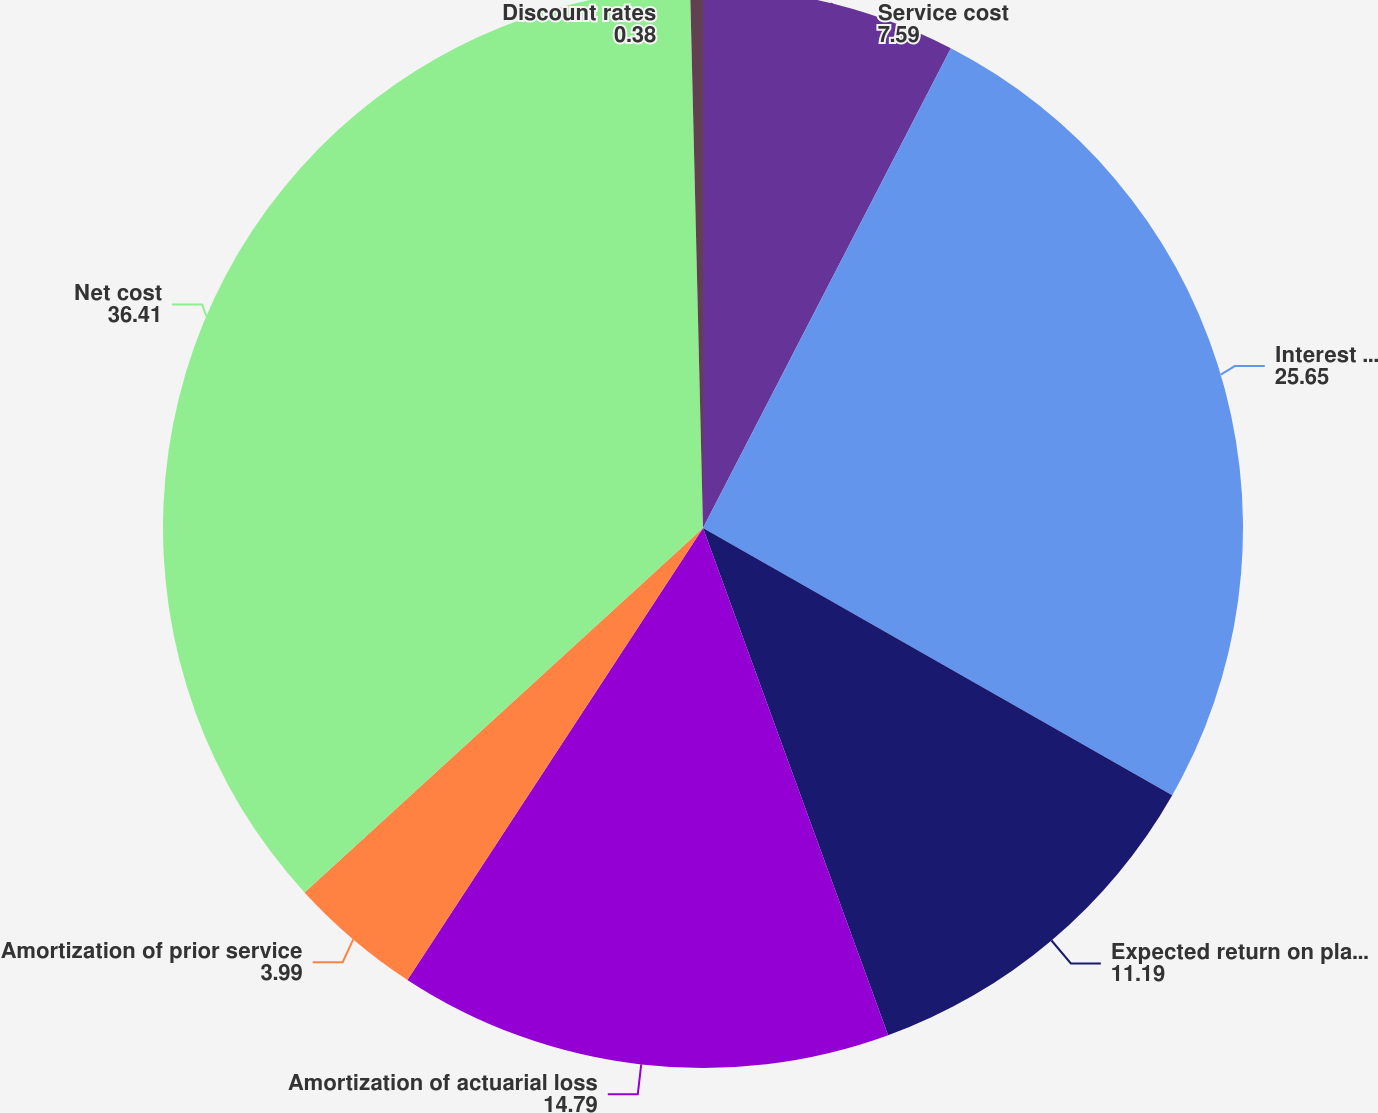Convert chart. <chart><loc_0><loc_0><loc_500><loc_500><pie_chart><fcel>Service cost<fcel>Interest cost<fcel>Expected return on plan assets<fcel>Amortization of actuarial loss<fcel>Amortization of prior service<fcel>Net cost<fcel>Discount rates<nl><fcel>7.59%<fcel>25.65%<fcel>11.19%<fcel>14.79%<fcel>3.99%<fcel>36.41%<fcel>0.38%<nl></chart> 